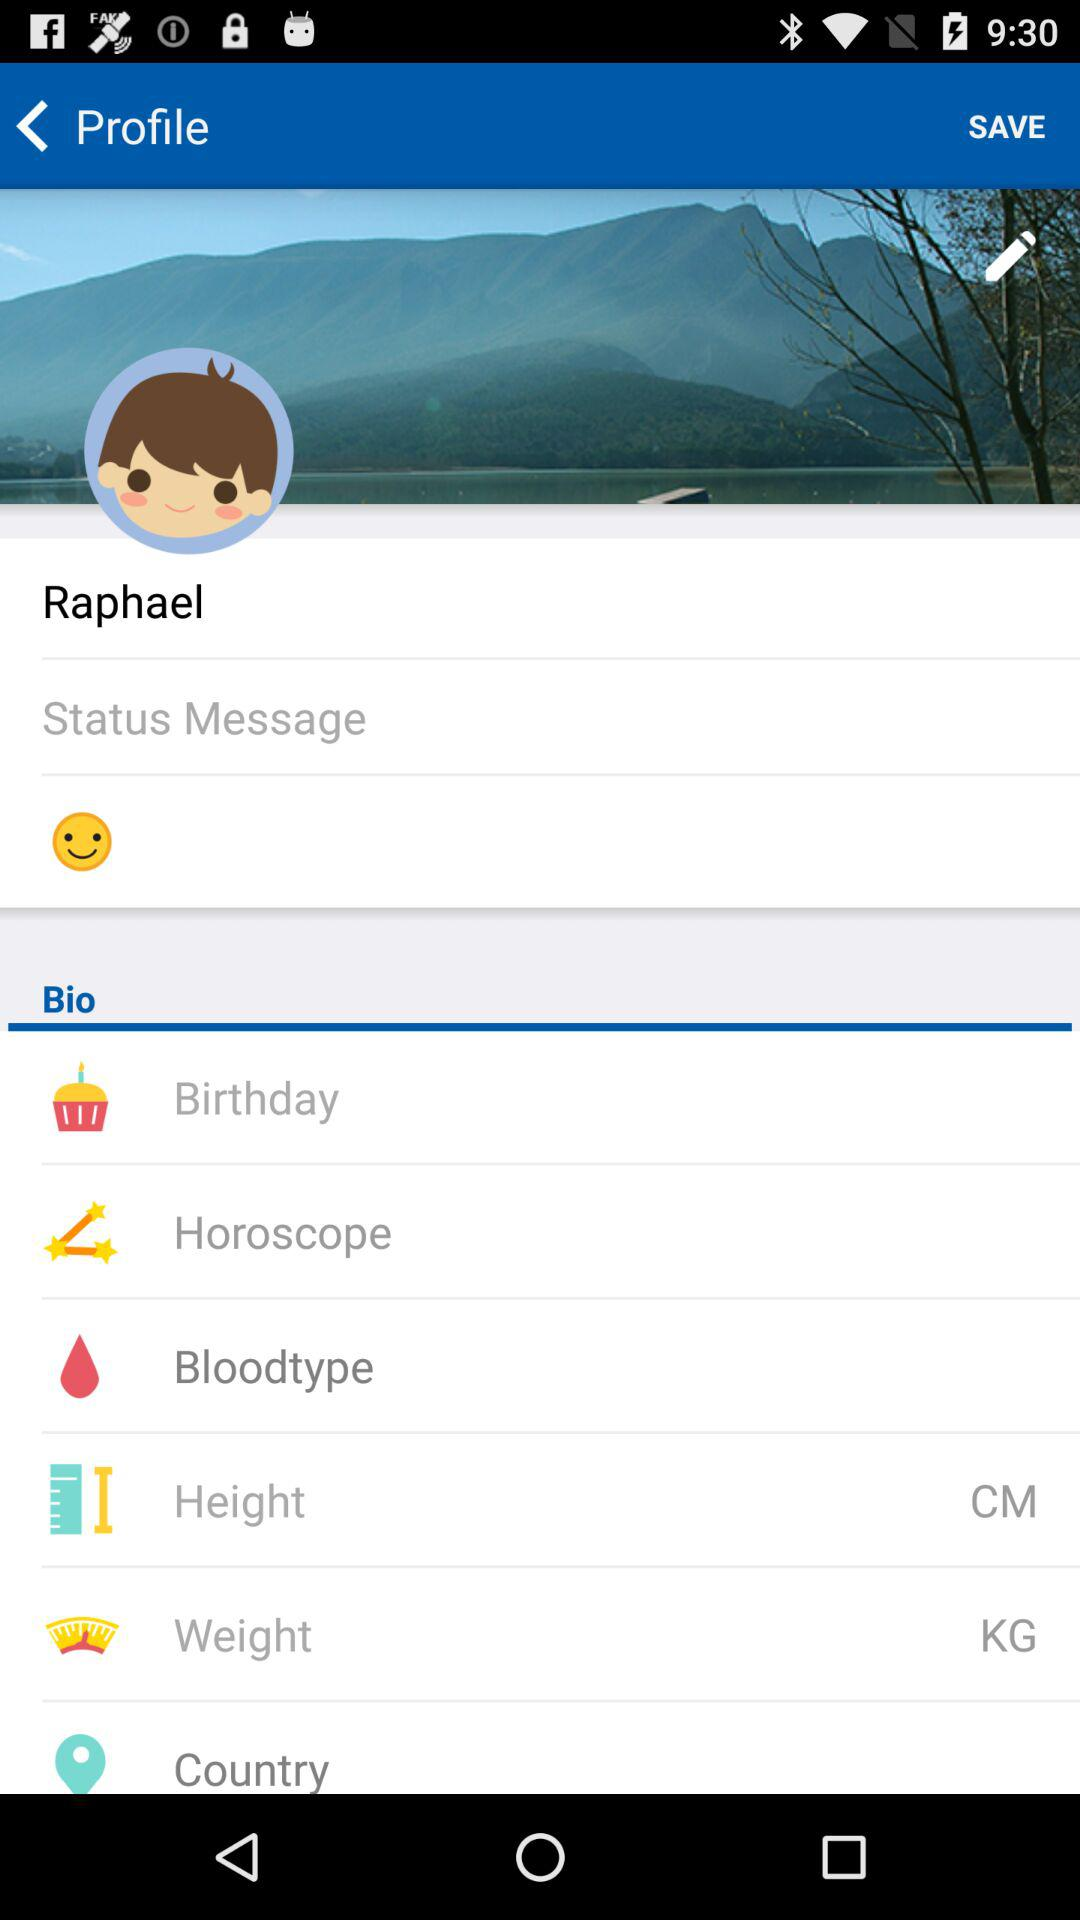What is the user name? The user name is Raphael. 